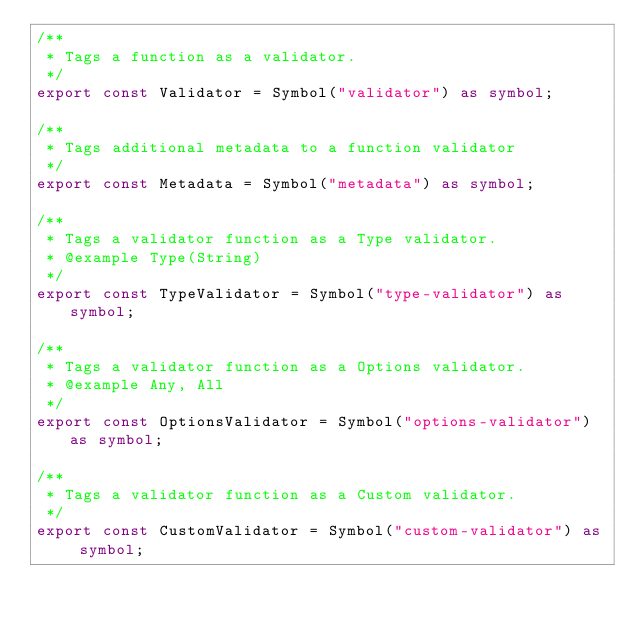Convert code to text. <code><loc_0><loc_0><loc_500><loc_500><_TypeScript_>/**
 * Tags a function as a validator.
 */
export const Validator = Symbol("validator") as symbol;

/**
 * Tags additional metadata to a function validator
 */
export const Metadata = Symbol("metadata") as symbol;

/**
 * Tags a validator function as a Type validator.
 * @example Type(String)
 */
export const TypeValidator = Symbol("type-validator") as symbol;

/**
 * Tags a validator function as a Options validator.
 * @example Any, All
 */
export const OptionsValidator = Symbol("options-validator") as symbol;

/**
 * Tags a validator function as a Custom validator.
 */
export const CustomValidator = Symbol("custom-validator") as symbol;
</code> 